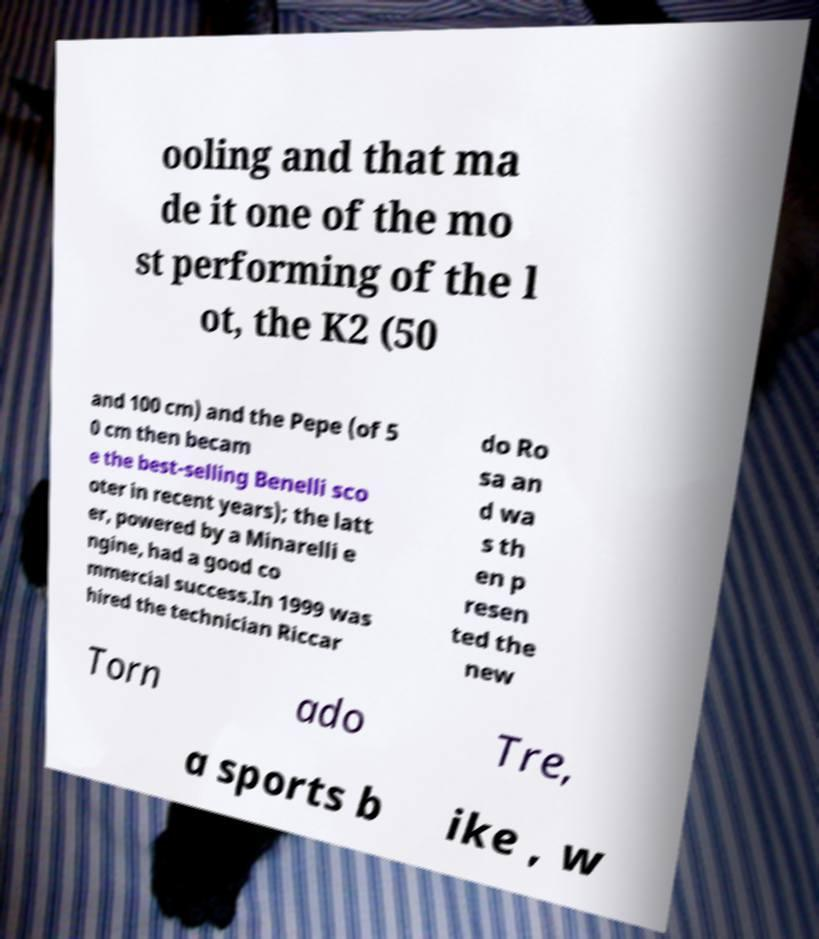Can you accurately transcribe the text from the provided image for me? ooling and that ma de it one of the mo st performing of the l ot, the K2 (50 and 100 cm) and the Pepe (of 5 0 cm then becam e the best-selling Benelli sco oter in recent years); the latt er, powered by a Minarelli e ngine, had a good co mmercial success.In 1999 was hired the technician Riccar do Ro sa an d wa s th en p resen ted the new Torn ado Tre, a sports b ike , w 